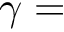Convert formula to latex. <formula><loc_0><loc_0><loc_500><loc_500>\gamma =</formula> 